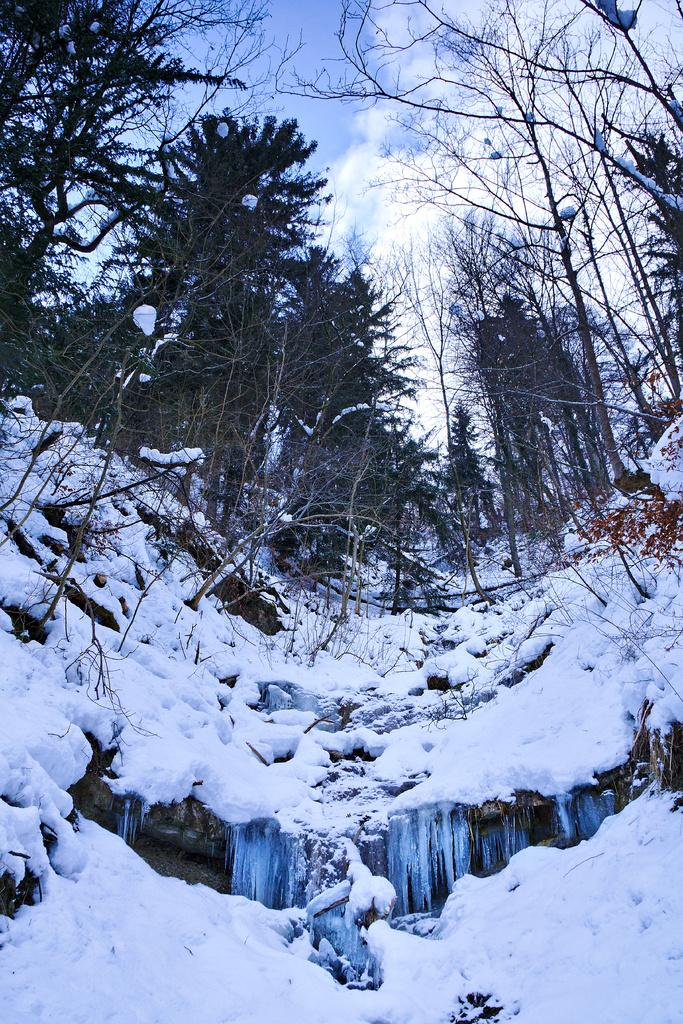What type of weather condition is depicted in the image? There is snow in the image, indicating a cold or wintry weather condition. What type of vegetation can be seen in the image? There are trees in the image. What is visible in the sky in the image? The sky is visible in the image, and clouds are present. What type of cherries can be seen growing on the trees in the image? There are no cherries present in the image; it features snow and trees without any specific fruit mentioned. 